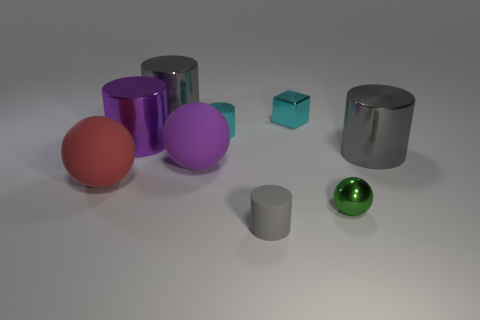There is a gray metal cylinder left of the metal ball; is it the same size as the cylinder in front of the small green ball?
Make the answer very short. No. How many objects are green balls or purple metal blocks?
Give a very brief answer. 1. There is a gray rubber thing on the right side of the large purple metal cylinder; what size is it?
Your answer should be compact. Small. There is a metallic object that is in front of the big sphere that is to the left of the large purple metal cylinder; how many large cylinders are in front of it?
Your response must be concise. 0. Does the tiny cube have the same color as the tiny metal cylinder?
Provide a succinct answer. Yes. How many gray objects are in front of the tiny cube and behind the big red matte thing?
Your answer should be compact. 1. The large rubber object on the right side of the red sphere has what shape?
Provide a succinct answer. Sphere. Are there fewer tiny cyan cylinders behind the tiny cyan metallic cylinder than tiny cyan metallic things that are behind the tiny gray rubber cylinder?
Offer a very short reply. Yes. Is the material of the gray cylinder left of the tiny rubber cylinder the same as the tiny object that is to the left of the tiny gray object?
Your answer should be compact. Yes. There is a red rubber thing; what shape is it?
Make the answer very short. Sphere. 